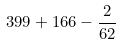<formula> <loc_0><loc_0><loc_500><loc_500>3 9 9 + 1 6 6 - \frac { 2 } { 6 2 }</formula> 